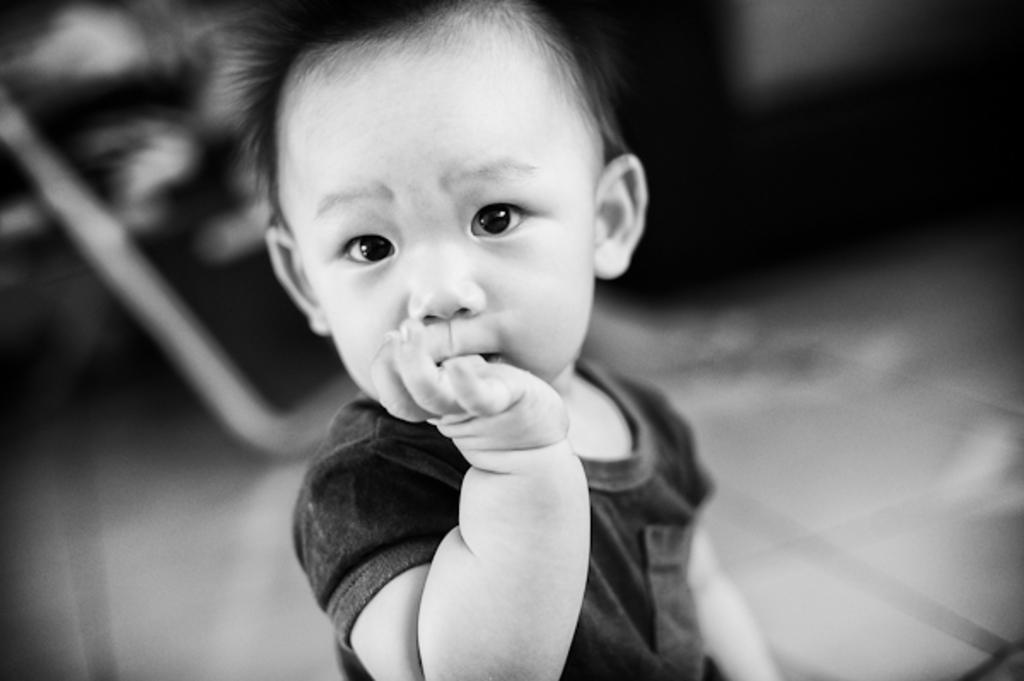What is the main subject in the foreground of the image? There is a kid in the foreground of the image. How would you describe the background of the image? The background of the image is blurry. What type of bait is the kid using in the image? There is no bait present in the image; it features a kid in the foreground with a blurry background. What kind of beam is supporting the structure in the image? There is no structure or beam present in the image; it only shows a kid in the foreground and a blurry background. 